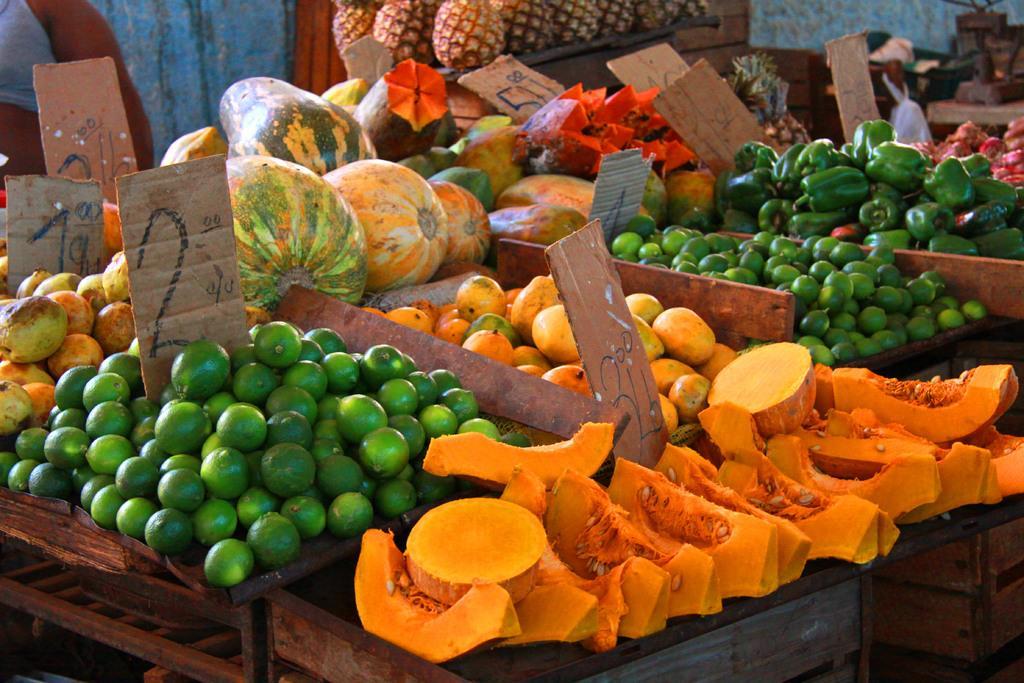In one or two sentences, can you explain what this image depicts? This image consists of fruits and vegetables kept on the desk. At the bottom, there are wooden boxes. In the background, there are pineapples. 